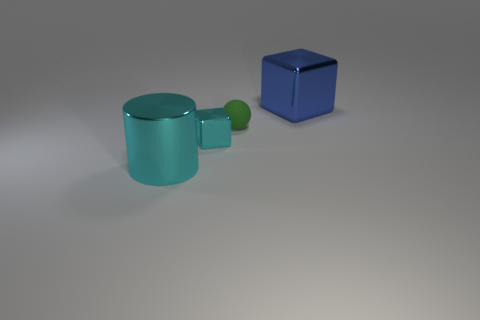How many other objects are there of the same shape as the tiny green object?
Offer a very short reply. 0. What size is the green matte thing?
Your answer should be very brief. Small. What shape is the large shiny thing that is to the right of the cyan cube?
Offer a very short reply. Cube. Does the big cylinder have the same material as the cyan object that is behind the big metallic cylinder?
Make the answer very short. Yes. Is the small cyan metal object the same shape as the large cyan metal object?
Provide a short and direct response. No. There is a large object that is the same shape as the small cyan metal object; what is it made of?
Your response must be concise. Metal. What is the color of the thing that is in front of the large blue shiny block and to the right of the small shiny thing?
Give a very brief answer. Green. What color is the small matte thing?
Provide a succinct answer. Green. What is the material of the large object that is the same color as the small block?
Keep it short and to the point. Metal. Is there a large blue thing of the same shape as the small cyan object?
Your answer should be compact. Yes. 